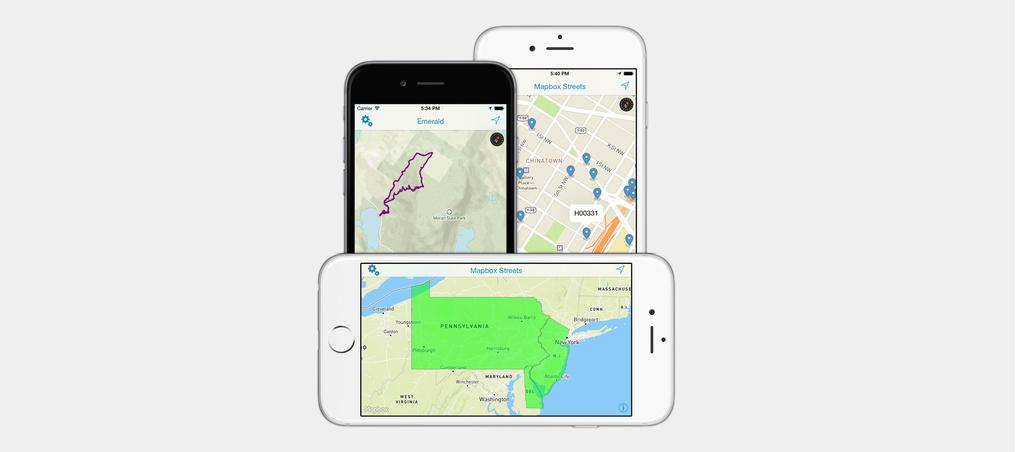<image>
Describe the image concisely. A black phone has the word Emerald at the top, and sits with two white phones. 